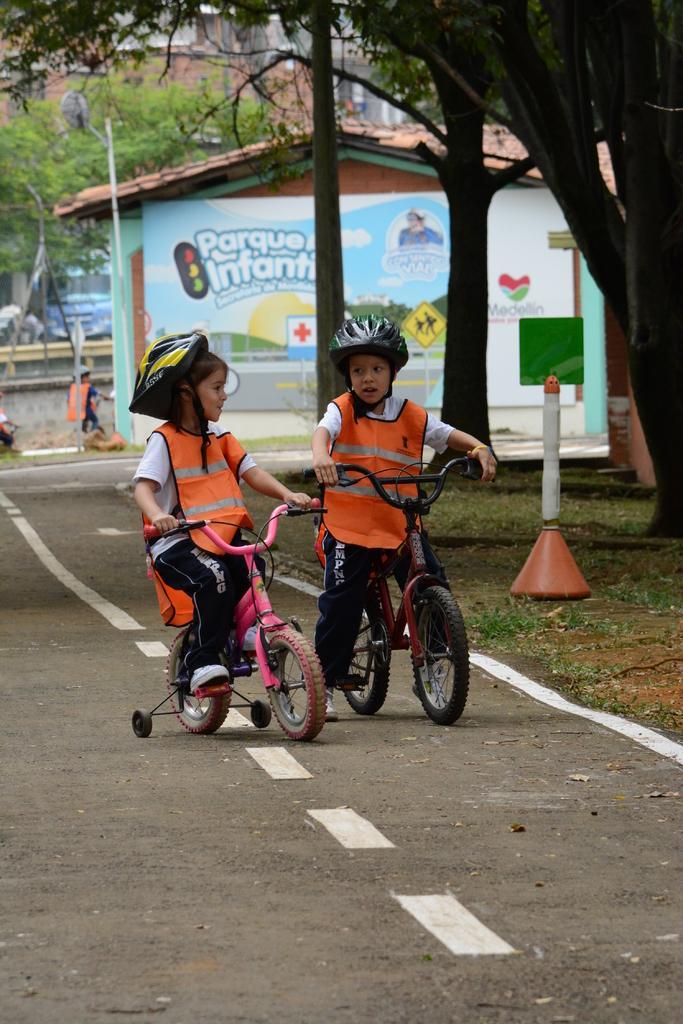In one or two sentences, can you explain what this image depicts? In this image, we can see kids wearing jackets and helmets and riding on the bicycles. In the background, there are buildings and we can see a shed, a traffic cone, trees, poles and we can see some other people and vehicles. At the bottom, there is a road. 